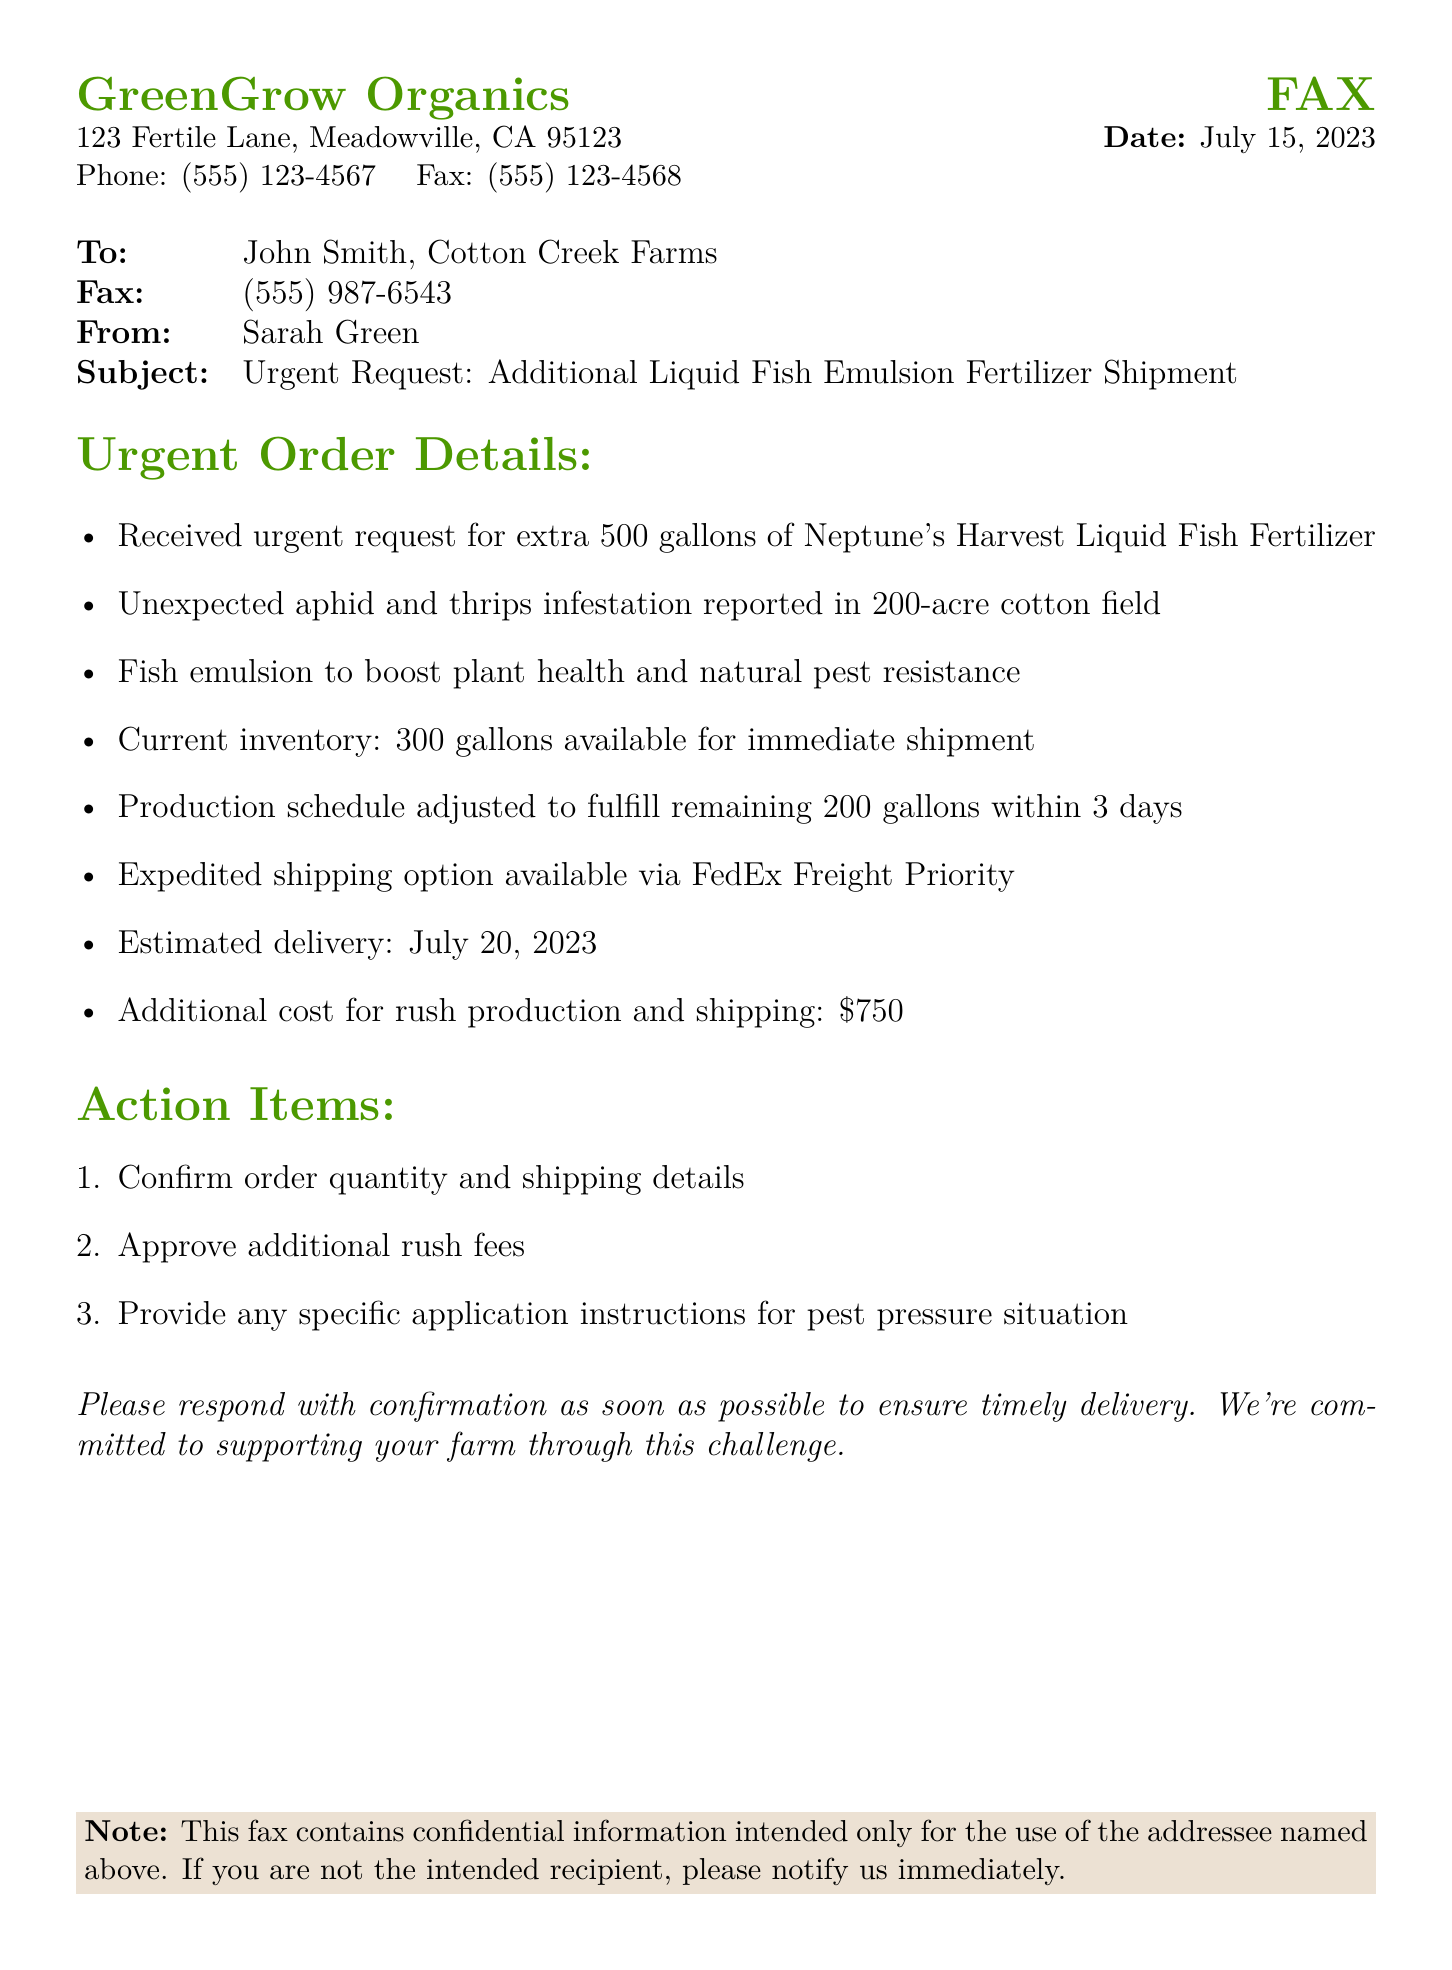What is the name of the sender? The sender is identified in the document as Sarah Green.
Answer: Sarah Green What is the urgent request related to? The urgent request is for an additional shipment of liquid fish emulsion fertilizer due to pest pressure.
Answer: Liquid fish emulsion fertilizer How many gallons of fertilizer are requested? The fax specifies a request for an extra 500 gallons of liquid fish emulsion fertilizer.
Answer: 500 gallons What is the expected delivery date? The document states the estimated delivery date is July 20, 2023.
Answer: July 20, 2023 What is the additional cost for rush production and shipping? The cost specified for rush production and shipping is $750.
Answer: $750 What crop is affected by the pest infestation? The document mentions that the cotton field is affected by the pest infestation.
Answer: Cotton How much liquid fish fertilizer is currently available for shipment? The current inventory available for immediate shipment is 300 gallons.
Answer: 300 gallons What type of shipping option is mentioned? The fax mentions an expedited shipping option via FedEx Freight Priority.
Answer: FedEx Freight Priority What is one action item listed in the document? One action item is to confirm order quantity and shipping details.
Answer: Confirm order quantity and shipping details 